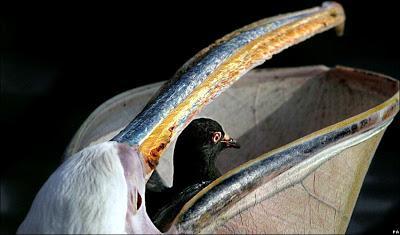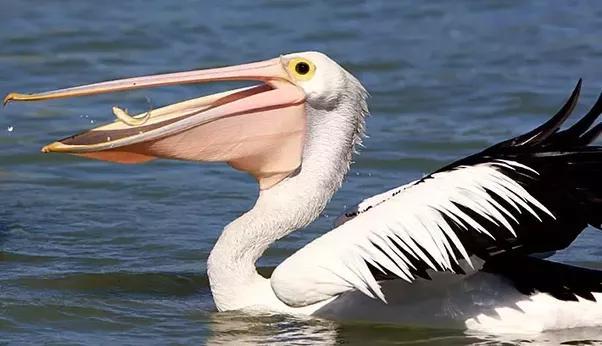The first image is the image on the left, the second image is the image on the right. Analyze the images presented: Is the assertion "The bird in the left image is facing towards the left." valid? Answer yes or no. No. The first image is the image on the left, the second image is the image on the right. Analyze the images presented: Is the assertion "An image shows a leftward floating pelican with a fish in its bill." valid? Answer yes or no. Yes. 